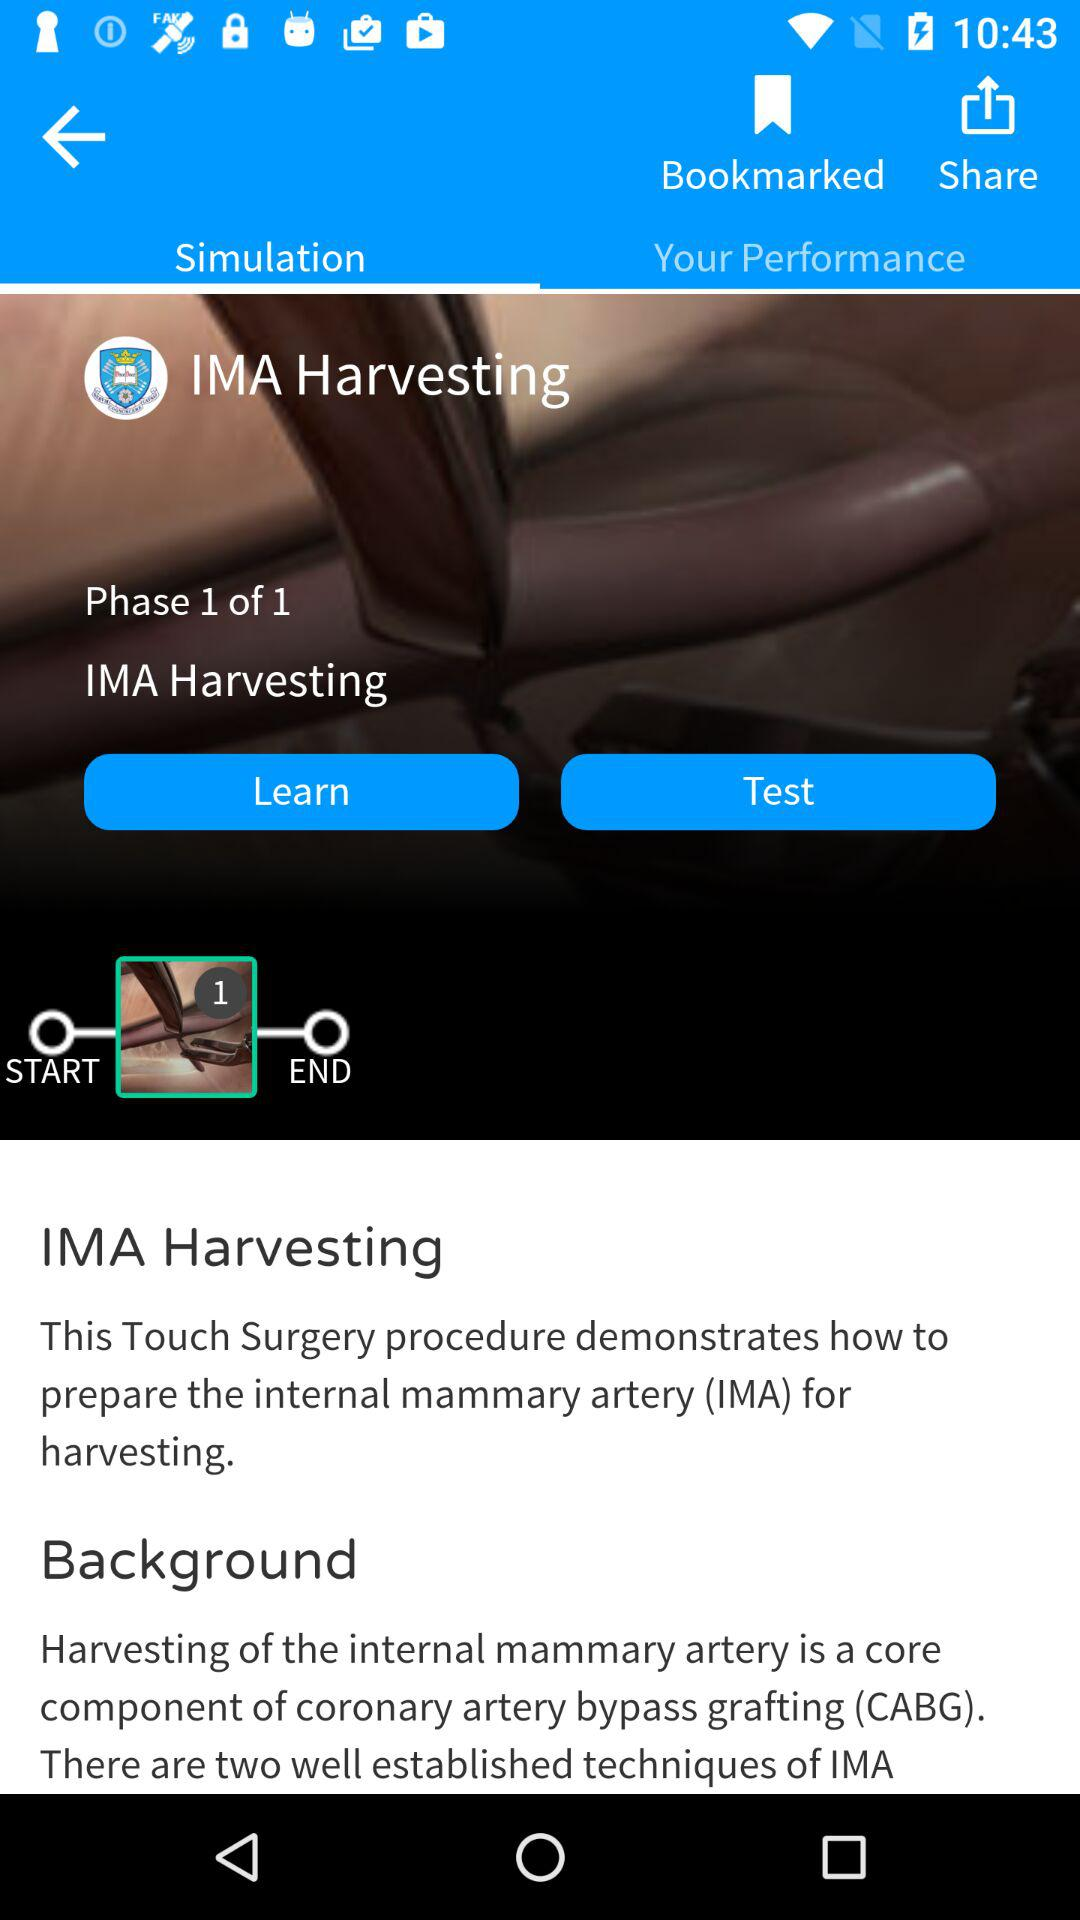What is the full form of IMA? The full form of IMA is "Internal Mammary Artery". 